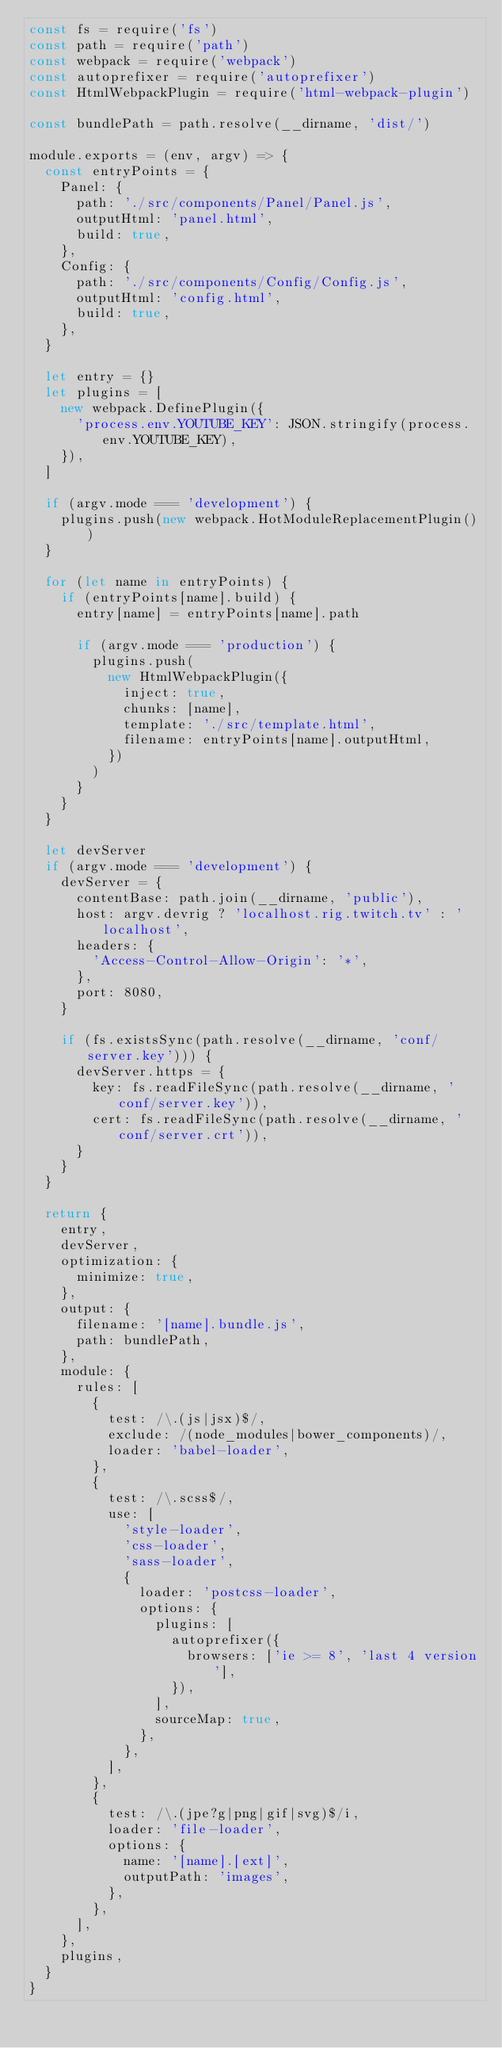<code> <loc_0><loc_0><loc_500><loc_500><_JavaScript_>const fs = require('fs')
const path = require('path')
const webpack = require('webpack')
const autoprefixer = require('autoprefixer')
const HtmlWebpackPlugin = require('html-webpack-plugin')

const bundlePath = path.resolve(__dirname, 'dist/')

module.exports = (env, argv) => {
  const entryPoints = {
    Panel: {
      path: './src/components/Panel/Panel.js',
      outputHtml: 'panel.html',
      build: true,
    },
    Config: {
      path: './src/components/Config/Config.js',
      outputHtml: 'config.html',
      build: true,
    },
  }

  let entry = {}
  let plugins = [
    new webpack.DefinePlugin({
      'process.env.YOUTUBE_KEY': JSON.stringify(process.env.YOUTUBE_KEY),
    }),
  ]

  if (argv.mode === 'development') {
    plugins.push(new webpack.HotModuleReplacementPlugin())
  }

  for (let name in entryPoints) {
    if (entryPoints[name].build) {
      entry[name] = entryPoints[name].path

      if (argv.mode === 'production') {
        plugins.push(
          new HtmlWebpackPlugin({
            inject: true,
            chunks: [name],
            template: './src/template.html',
            filename: entryPoints[name].outputHtml,
          })
        )
      }
    }
  }

  let devServer
  if (argv.mode === 'development') {
    devServer = {
      contentBase: path.join(__dirname, 'public'),
      host: argv.devrig ? 'localhost.rig.twitch.tv' : 'localhost',
      headers: {
        'Access-Control-Allow-Origin': '*',
      },
      port: 8080,
    }

    if (fs.existsSync(path.resolve(__dirname, 'conf/server.key'))) {
      devServer.https = {
        key: fs.readFileSync(path.resolve(__dirname, 'conf/server.key')),
        cert: fs.readFileSync(path.resolve(__dirname, 'conf/server.crt')),
      }
    }
  }

  return {
    entry,
    devServer,
    optimization: {
      minimize: true,
    },
    output: {
      filename: '[name].bundle.js',
      path: bundlePath,
    },
    module: {
      rules: [
        {
          test: /\.(js|jsx)$/,
          exclude: /(node_modules|bower_components)/,
          loader: 'babel-loader',
        },
        {
          test: /\.scss$/,
          use: [
            'style-loader',
            'css-loader',
            'sass-loader',
            {
              loader: 'postcss-loader',
              options: {
                plugins: [
                  autoprefixer({
                    browsers: ['ie >= 8', 'last 4 version'],
                  }),
                ],
                sourceMap: true,
              },
            },
          ],
        },
        {
          test: /\.(jpe?g|png|gif|svg)$/i,
          loader: 'file-loader',
          options: {
            name: '[name].[ext]',
            outputPath: 'images',
          },
        },
      ],
    },
    plugins,
  }
}
</code> 